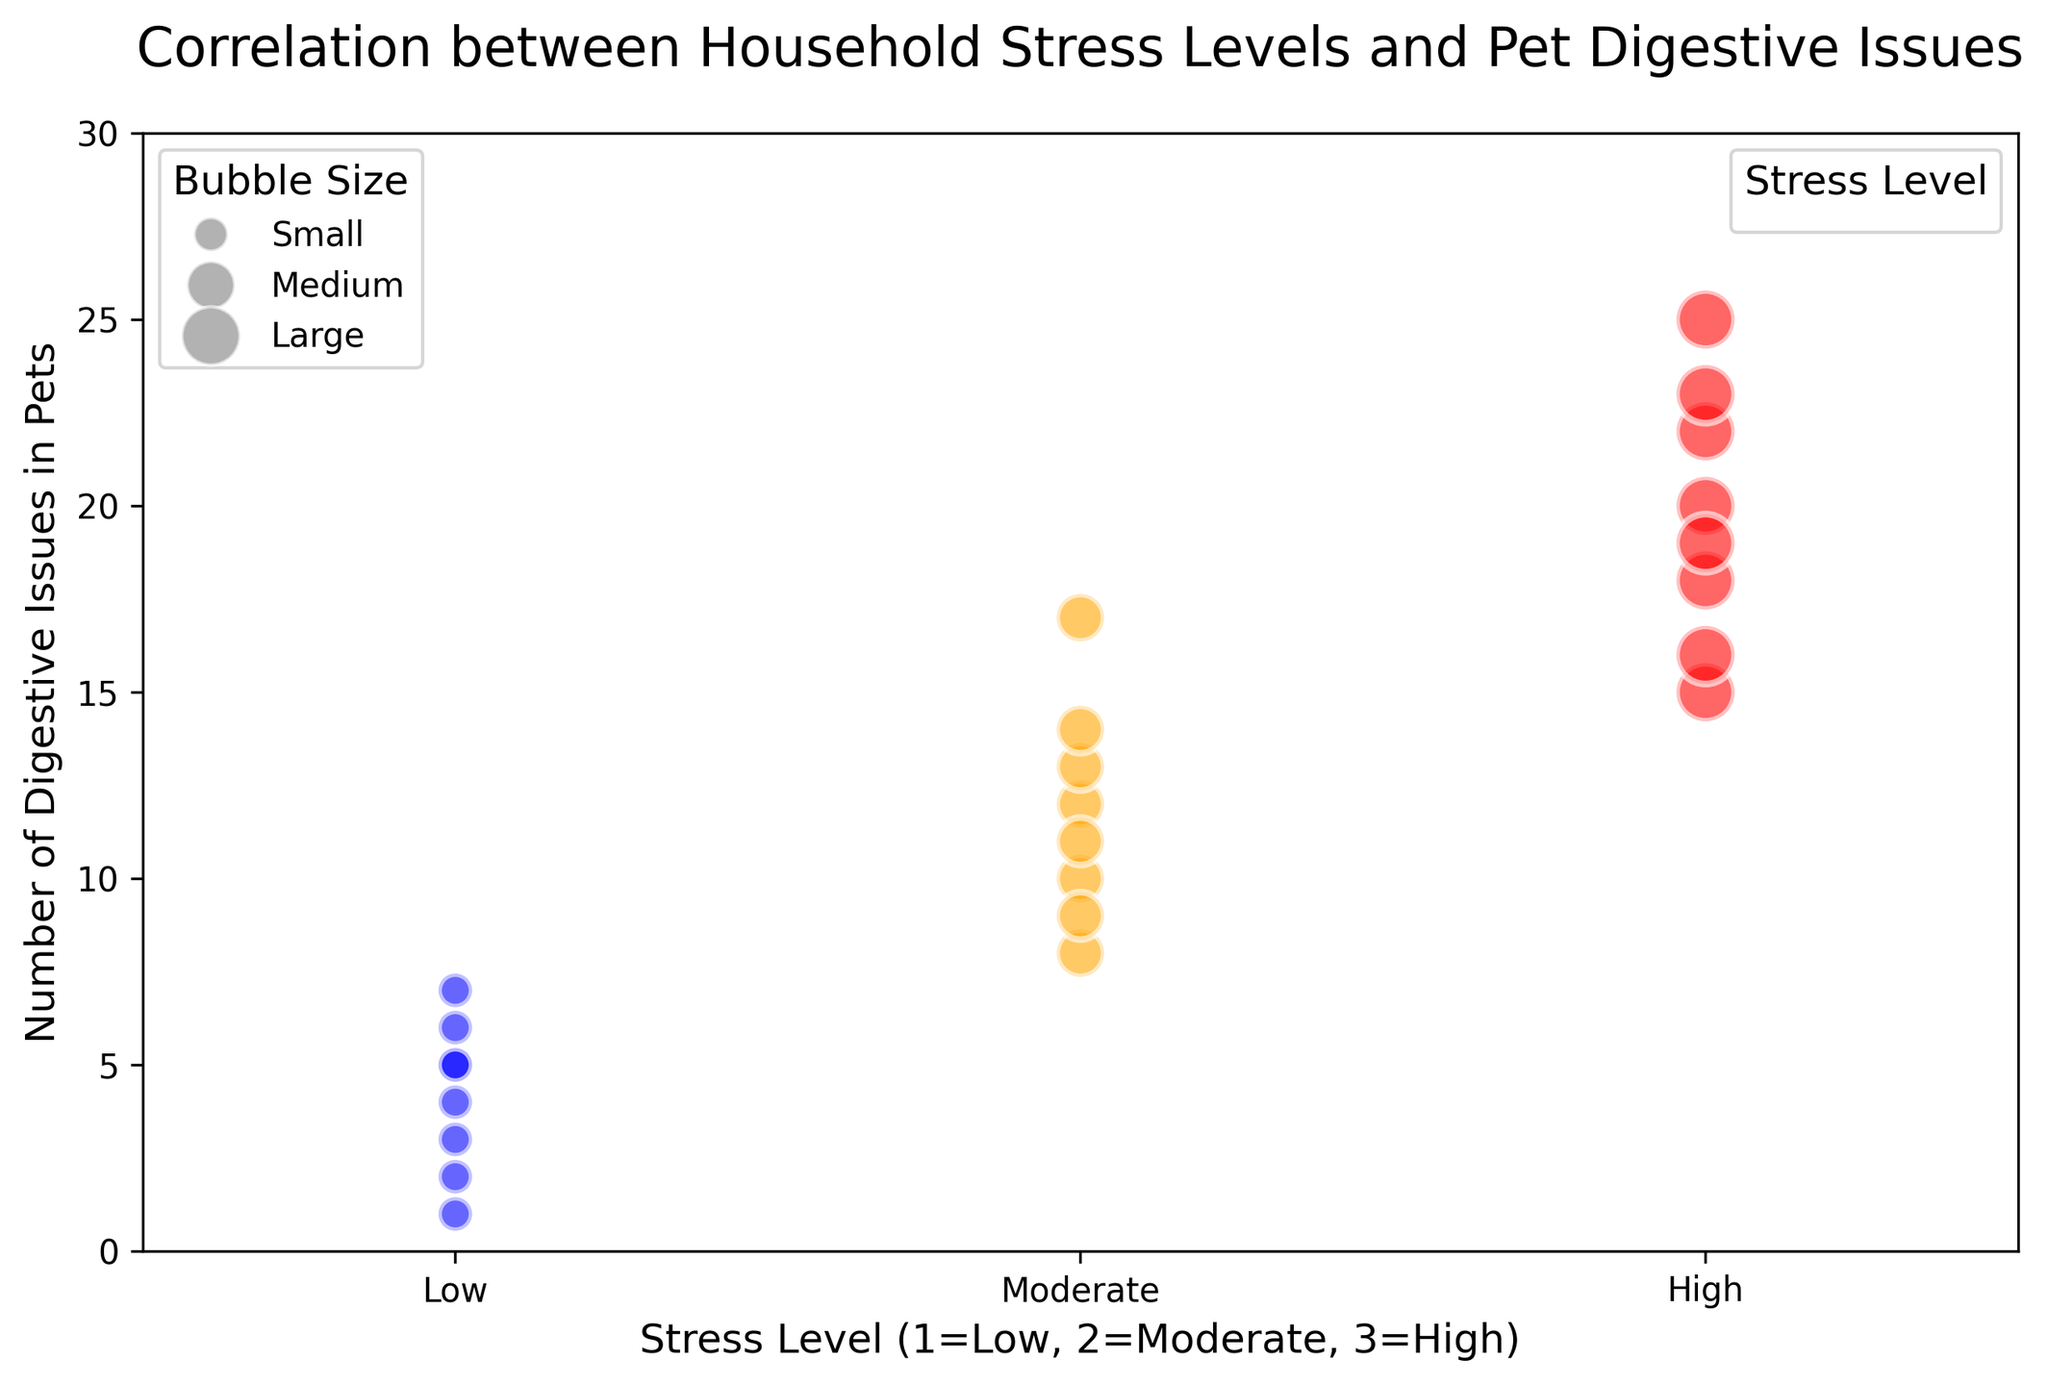What trend is observed between household stress levels and the number of pet digestive issues? As the household stress levels increase from Low to High, the number of pet digestive issues appears to also increase. Visually, the points representing 'High' stress levels are higher on the y-axis compared to 'Low' and 'Moderate' stress levels.
Answer: Higher stress levels correlate with more digestive issues Compare the digestive issues between pets in households with Moderate stress and High stress. Looking at the y-axis values, most of the points for 'High' stress levels have more digestive issues compared to 'Moderate' stress levels. The range for 'Moderate' stress levels is 8-17, while for 'High' stress levels is 15-25.
Answer: High stress averages more issues than Moderate stress What is the average number of digestive issues for pets in households with Low stress? The data points for Low stress levels have values 5, 3, 7, 2, 4, 1, 6, and 5. Summing them (5+3+7+2+4+1+6+5 = 33) and dividing by the number of points (8), the average is 33/8.
Answer: 4.125 Which stress level has more frequent occurrences of larger bubble sizes? Larger bubble sizes represent higher 'Bubble_Size' values. Observing the plot, the 'High' stress level bubbles appear larger and more frequent compared to 'Low' and 'Moderate'.
Answer: High stress Does average household income seem to affect the number of pet digestive issues? The average household income does not show a clear trend regarding the number of digestive issues. Both higher and lower household incomes are spread across different levels of digestive issues.
Answer: No clear effect Which stress level shows the widest variation in the number of pet digestive issues? 'Moderate' stress level shows a wider range from 8 to 17, compared to 'Low' and 'High'. Visually, the spread of 'Moderate' stress level points is more extended along the y-axis.
Answer: Moderate Calculate the total number of digestive issues for High-stress households. Summing the values for 'High' stress level (20, 15, 18, 22, 25, 19, 23, 16) gives a total of 158.
Answer: 158 Are there any overlaps in the number of digestive issues between Low and High-stress levels? Both 'Low' and 'High' stress levels share some overlapping values, such as 5 and 6 digestive issues.
Answer: Yes How does the bubble size vary with stress level? Low stress has the smallest bubbles, Moderate stress has medium-sized bubbles, and High stress has the largest bubbles, indicating how the 'Bubble_Size' scales with stress level.
Answer: Larger with higher stress levels 